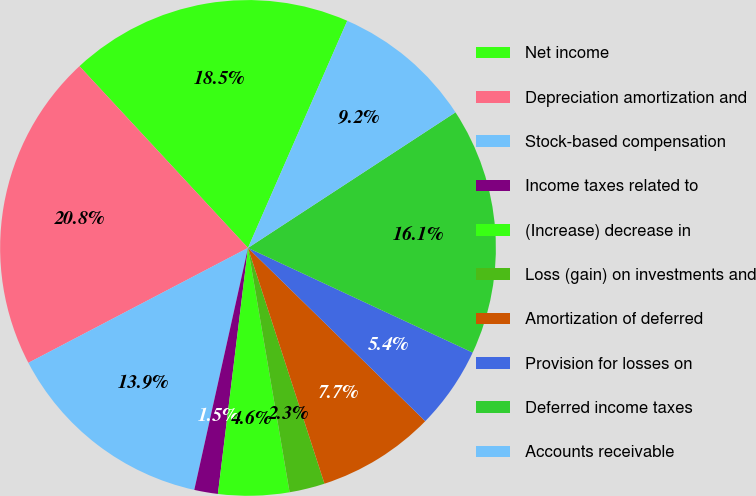Convert chart to OTSL. <chart><loc_0><loc_0><loc_500><loc_500><pie_chart><fcel>Net income<fcel>Depreciation amortization and<fcel>Stock-based compensation<fcel>Income taxes related to<fcel>(Increase) decrease in<fcel>Loss (gain) on investments and<fcel>Amortization of deferred<fcel>Provision for losses on<fcel>Deferred income taxes<fcel>Accounts receivable<nl><fcel>18.46%<fcel>20.77%<fcel>13.85%<fcel>1.54%<fcel>4.62%<fcel>2.31%<fcel>7.69%<fcel>5.38%<fcel>16.15%<fcel>9.23%<nl></chart> 